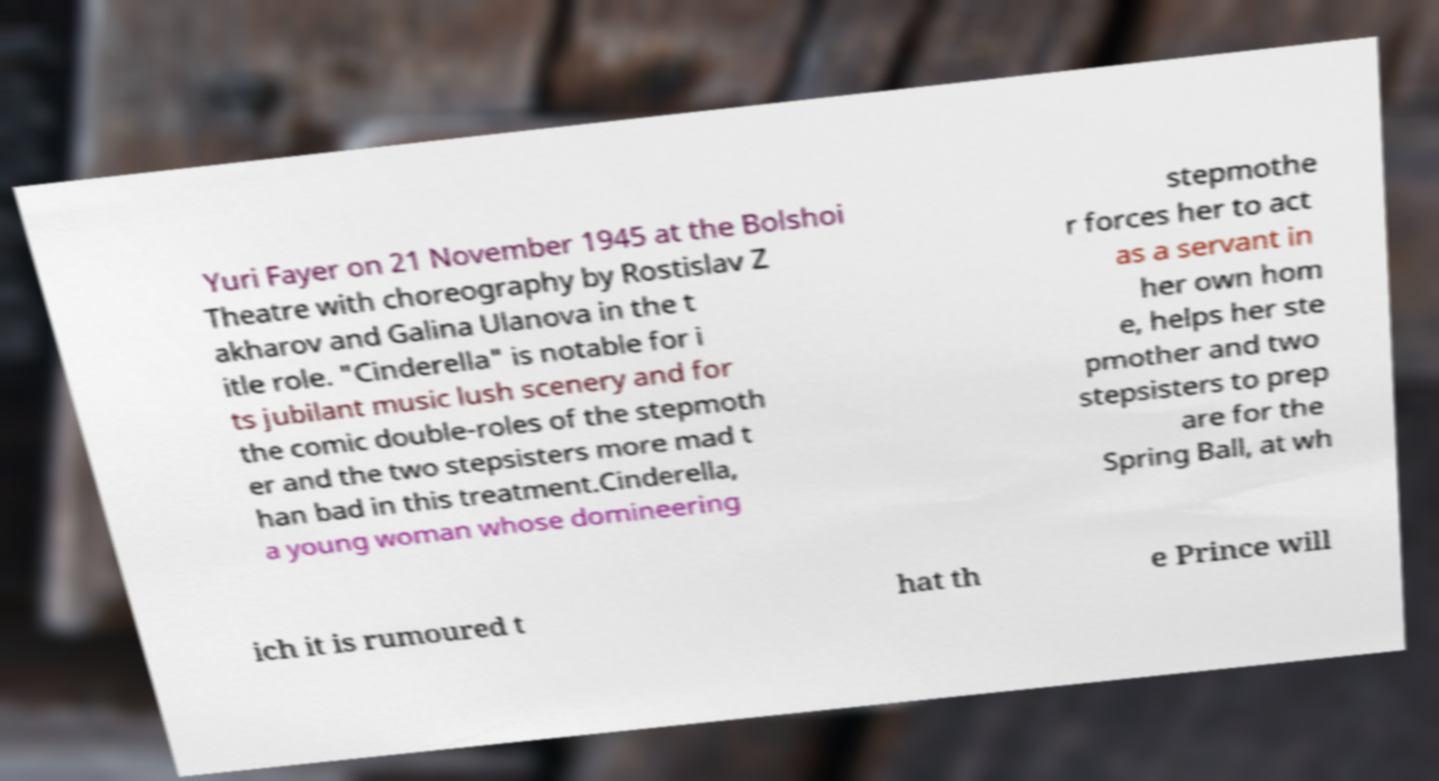For documentation purposes, I need the text within this image transcribed. Could you provide that? Yuri Fayer on 21 November 1945 at the Bolshoi Theatre with choreography by Rostislav Z akharov and Galina Ulanova in the t itle role. "Cinderella" is notable for i ts jubilant music lush scenery and for the comic double-roles of the stepmoth er and the two stepsisters more mad t han bad in this treatment.Cinderella, a young woman whose domineering stepmothe r forces her to act as a servant in her own hom e, helps her ste pmother and two stepsisters to prep are for the Spring Ball, at wh ich it is rumoured t hat th e Prince will 